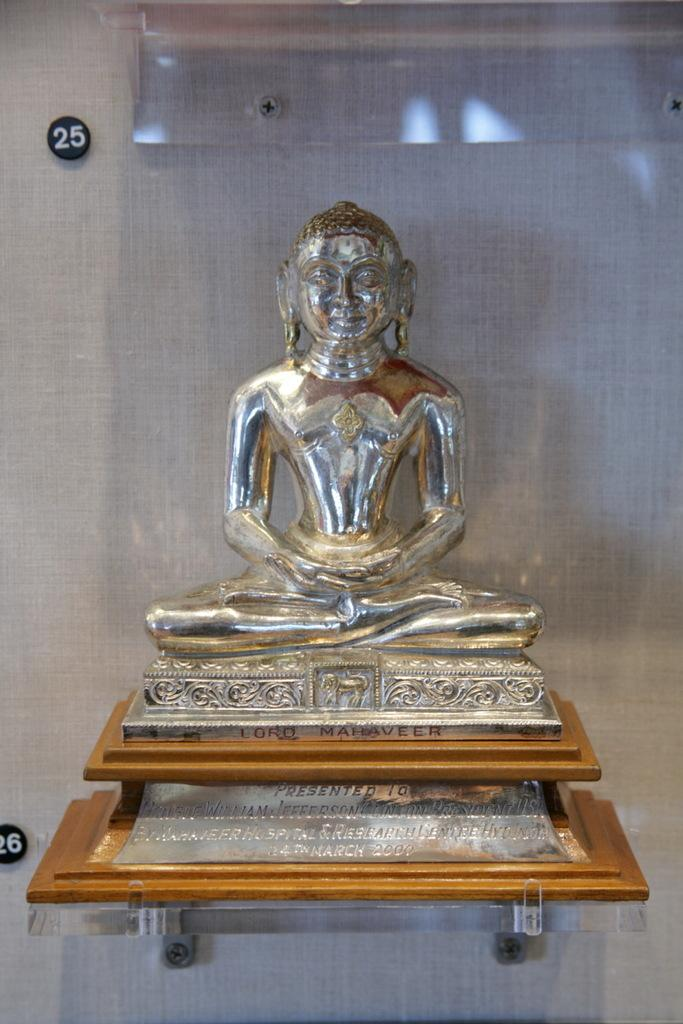What is the main subject of the image? There is a sculpture of a person sitting in the image. What is the color of the sculpture? The sculpture is silver in color. What can be seen in the background of the image? The background of the image is white. What type of sofa is depicted in the image? There is no sofa present in the image; it features a silver sculpture of a person sitting. What trade agreement is being discussed in the image? There is no discussion of trade agreements in the image; it is a static image of a silver sculpture. 